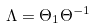Convert formula to latex. <formula><loc_0><loc_0><loc_500><loc_500>\Lambda = \Theta _ { 1 } \Theta ^ { - 1 }</formula> 